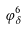<formula> <loc_0><loc_0><loc_500><loc_500>\varphi _ { \delta } ^ { 6 }</formula> 